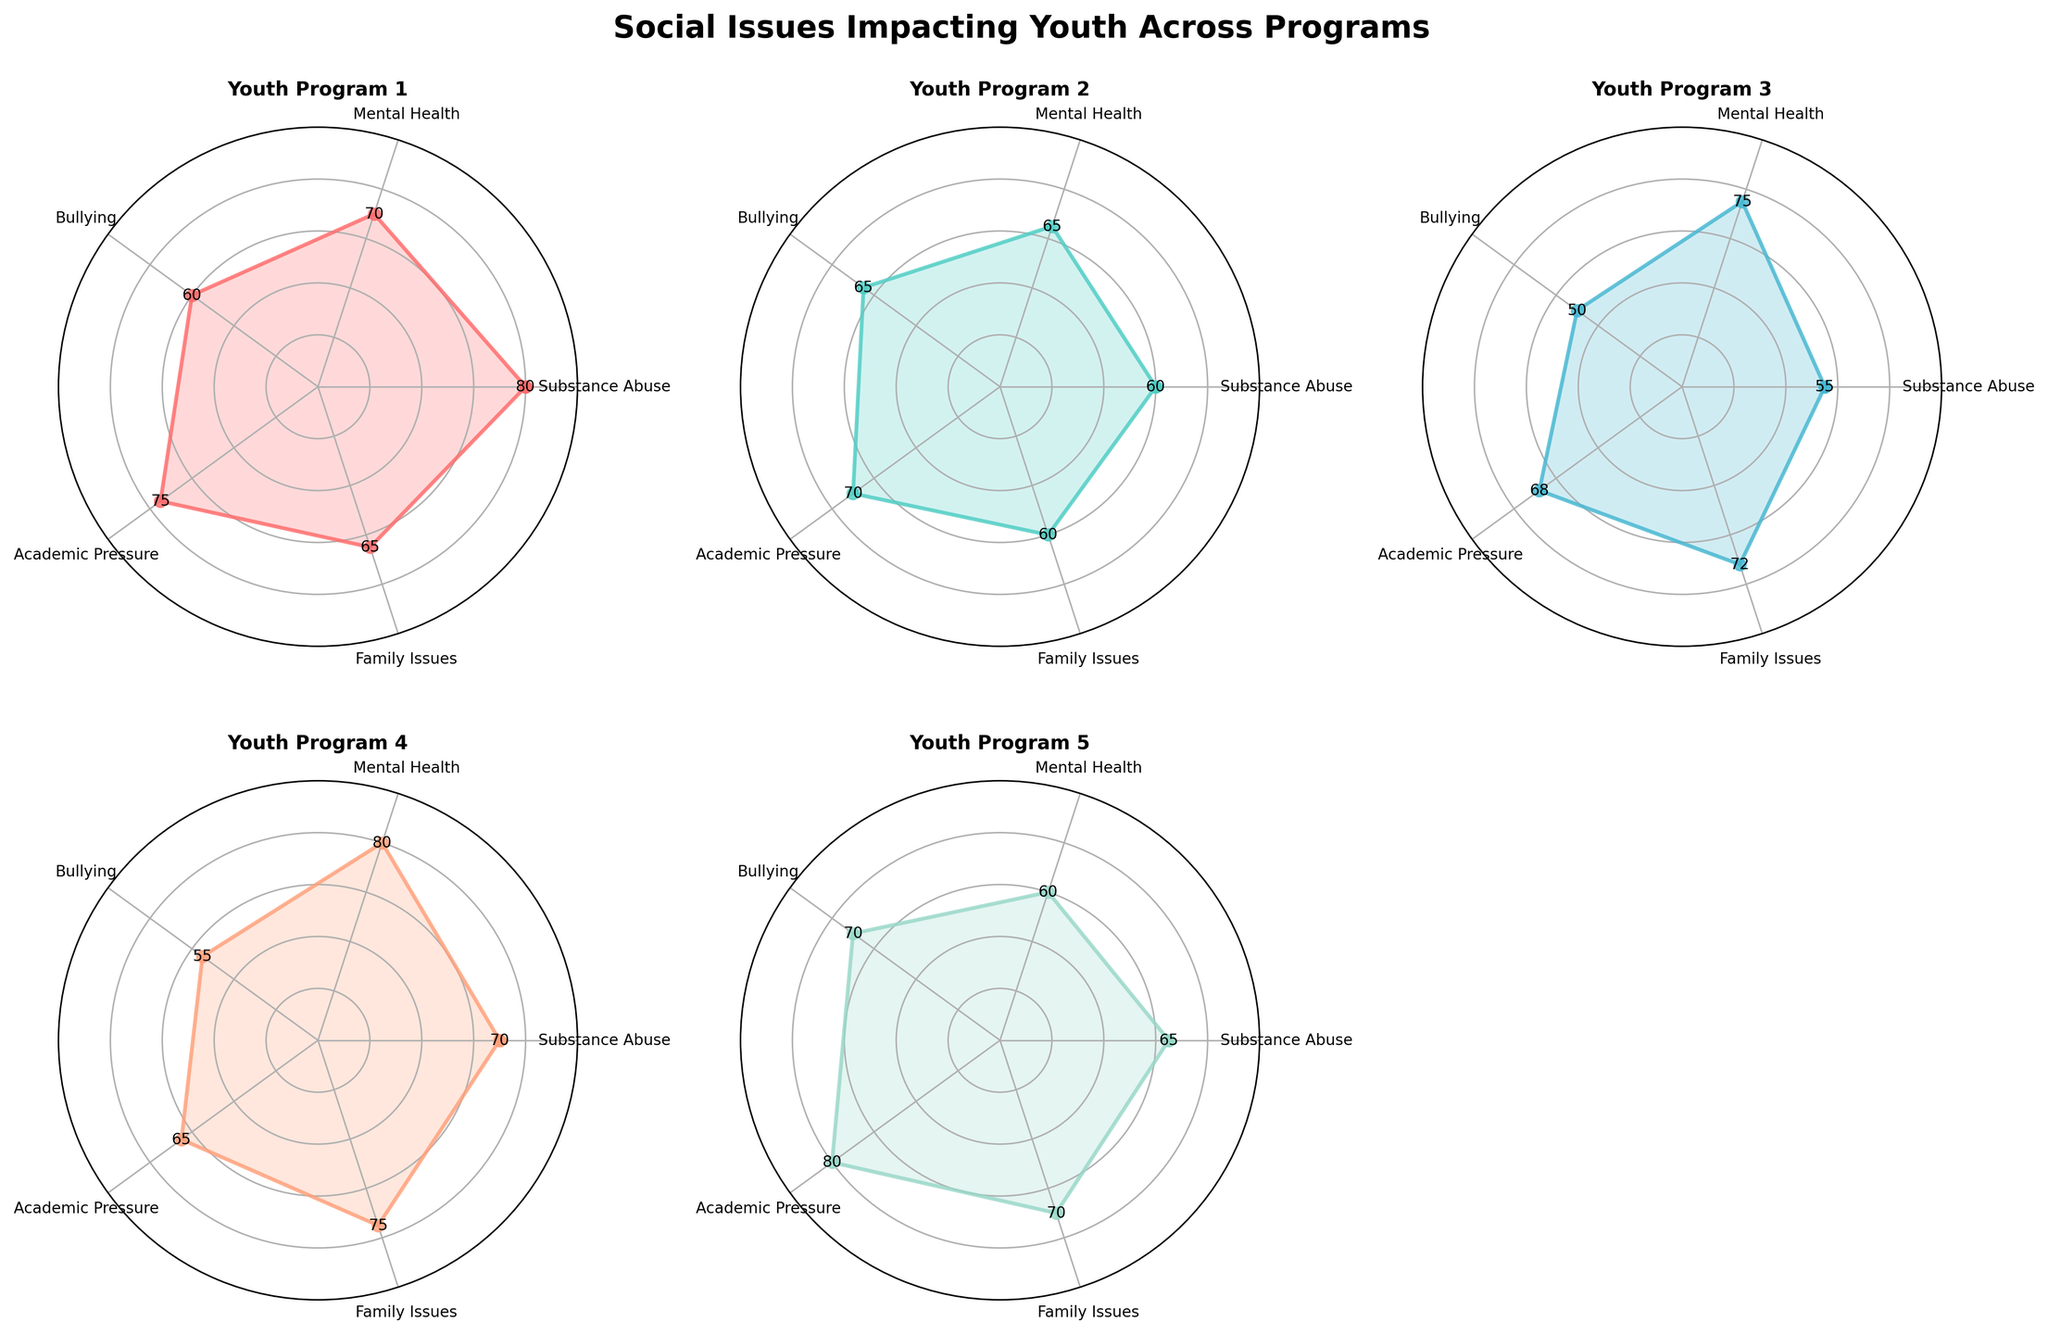What are the common categories across all radar charts? Each radar chart represents a single youth program which evaluates the same five categories: Substance Abuse, Mental Health, Bullying, Academic Pressure, and Family Issues. These categories are found as labels around the charts.
Answer: Substance Abuse, Mental Health, Bullying, Academic Pressure, Family Issues What is the title of the figure? The title is displayed at the top center of the figure. It encapsulates the overall theme of the radar charts which reflects the social issues impacting youth across different programs.
Answer: Social Issues Impacting Youth Across Programs Which youth program has the highest concern for Academic Pressure? Locate the value for Academic Pressure on each radar chart. Youth Program 5 has the longest spoke for Academic Pressure, indicating the highest value.
Answer: Youth Program 5 What is the average value of Family Issues for Youth Programs 1 and 3? To find the average, sum the Family Issues values for Youth Programs 1 (65) and 3 (72) and divide by 2. (65 + 72) / 2 = 68.5.
Answer: 68.5 Which program has the smallest range of values? Find the difference between the highest and lowest value for each program, and compare them. Youth Program 3 has values from 50 to 75, so the range is 75 - 50 = 25, which is the smallest among the programs.
Answer: Youth Program 3 How does Mental Health compare between Youth Program 2 and Youth Program 4? Look at the values for the Mental Health category in both programs. Youth Program 2 has 65 and Youth Program 4 has 80, indicating that Youth Program 4 has higher concerns regarding Mental Health.
Answer: Youth Program 4 has higher Mental Health concern Which program has the most balanced concerns across all categories? A balanced radar chart will have values that are closer to each other. Youth Program 2 has values: Substance Abuse (60), Mental Health (65), Bullying (65), Academic Pressure (70), Family Issues (60). These values are relatively close.
Answer: Youth Program 2 What is the sum of Bullying values across all youth programs? Add the Bullying values from each program: 60 (Program 1) + 65 (Program 2) + 50 (Program 3) + 55 (Program 4) + 70 (Program 5). The sum is 60 + 65 + 50 + 55 + 70 = 300.
Answer: 300 Which program has the highest concern for Family Issues? Find the Family Issues values across all radar charts. Youth Program 4 has the highest with a value of 75.
Answer: Youth Program 4 What is the maximum difference between any two values within Youth Program 1? Find the difference between the highest (80 for Substance Abuse) and the lowest value (60 for Bullying). The difference is 80 - 60 = 20.
Answer: 20 